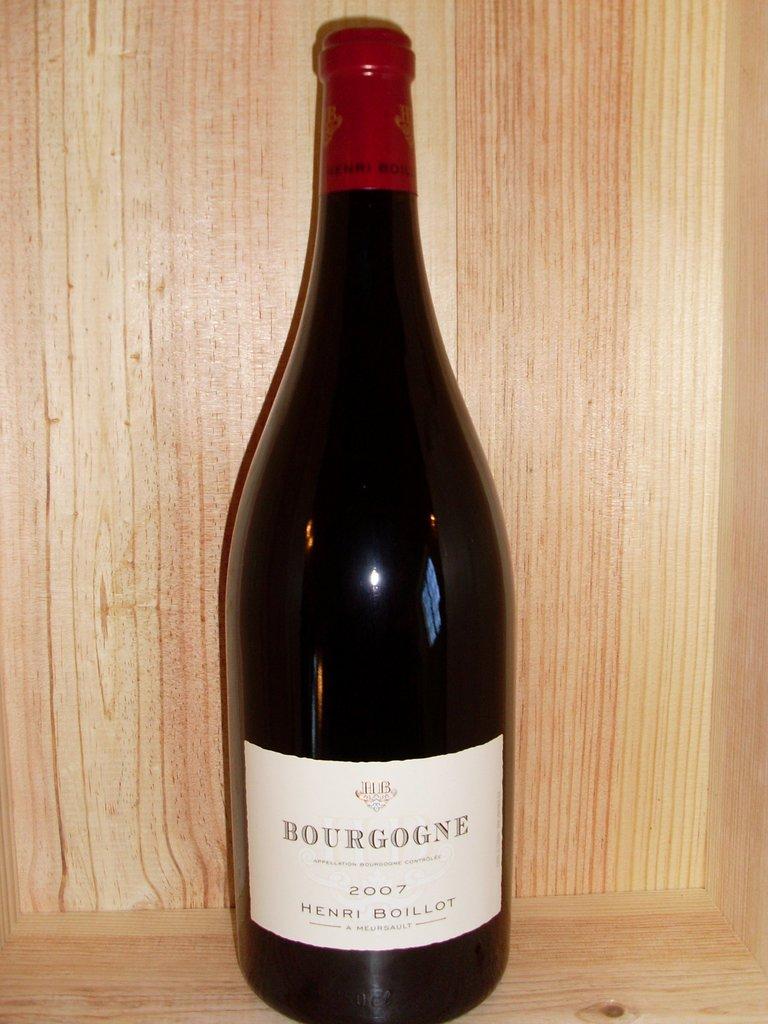What year is the wine?
Your answer should be very brief. 2007. 